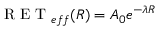<formula> <loc_0><loc_0><loc_500><loc_500>R E T _ { e f f } ( R ) = A _ { 0 } e ^ { - \lambda R }</formula> 